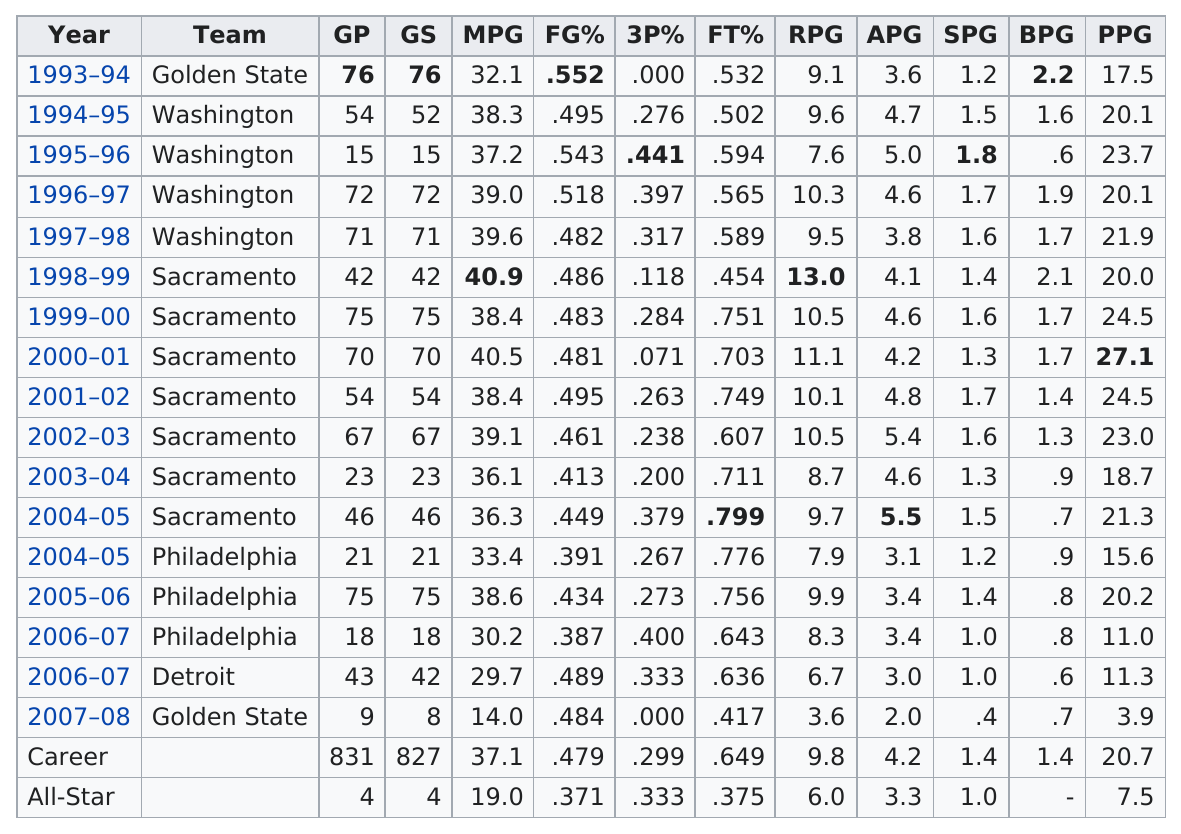Point out several critical features in this image. Webber averaged over 20 points per game in 11 out of his seasons. 